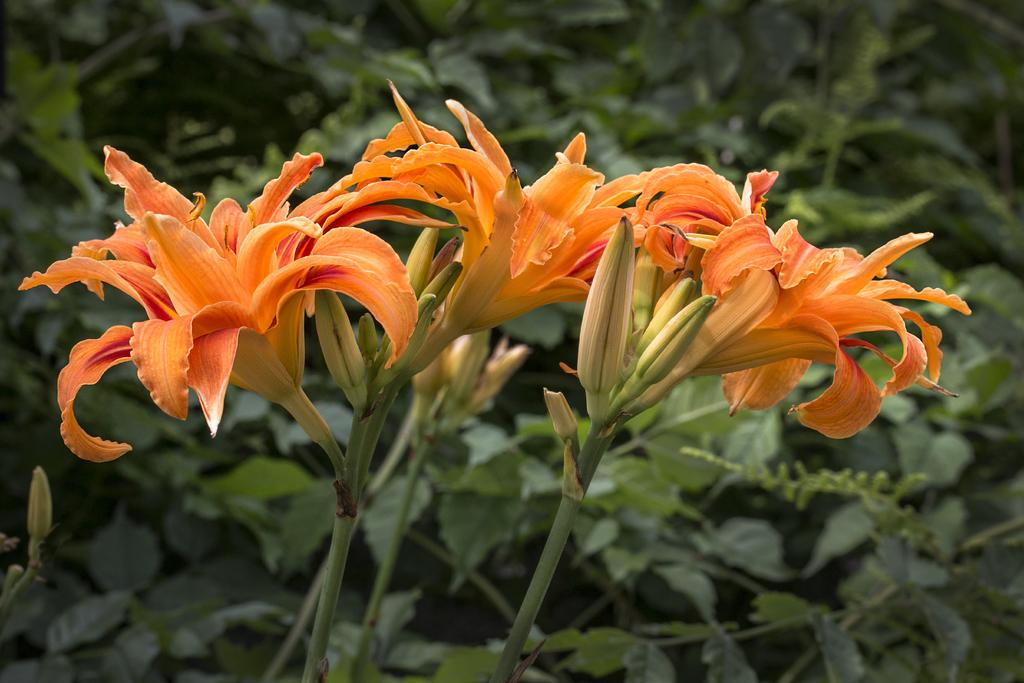What type of living organisms can be seen in the image? There are flowers in the image, which are associated with plants. What is the relationship between the flowers and the plants? The flowers are part of the plants, growing on them. How is the background of the flowers depicted in the image? The background of the flowers is blurred. What type of instrument is being played in the background of the image? There is no instrument present in the image; it features flowers with a blurred background. 